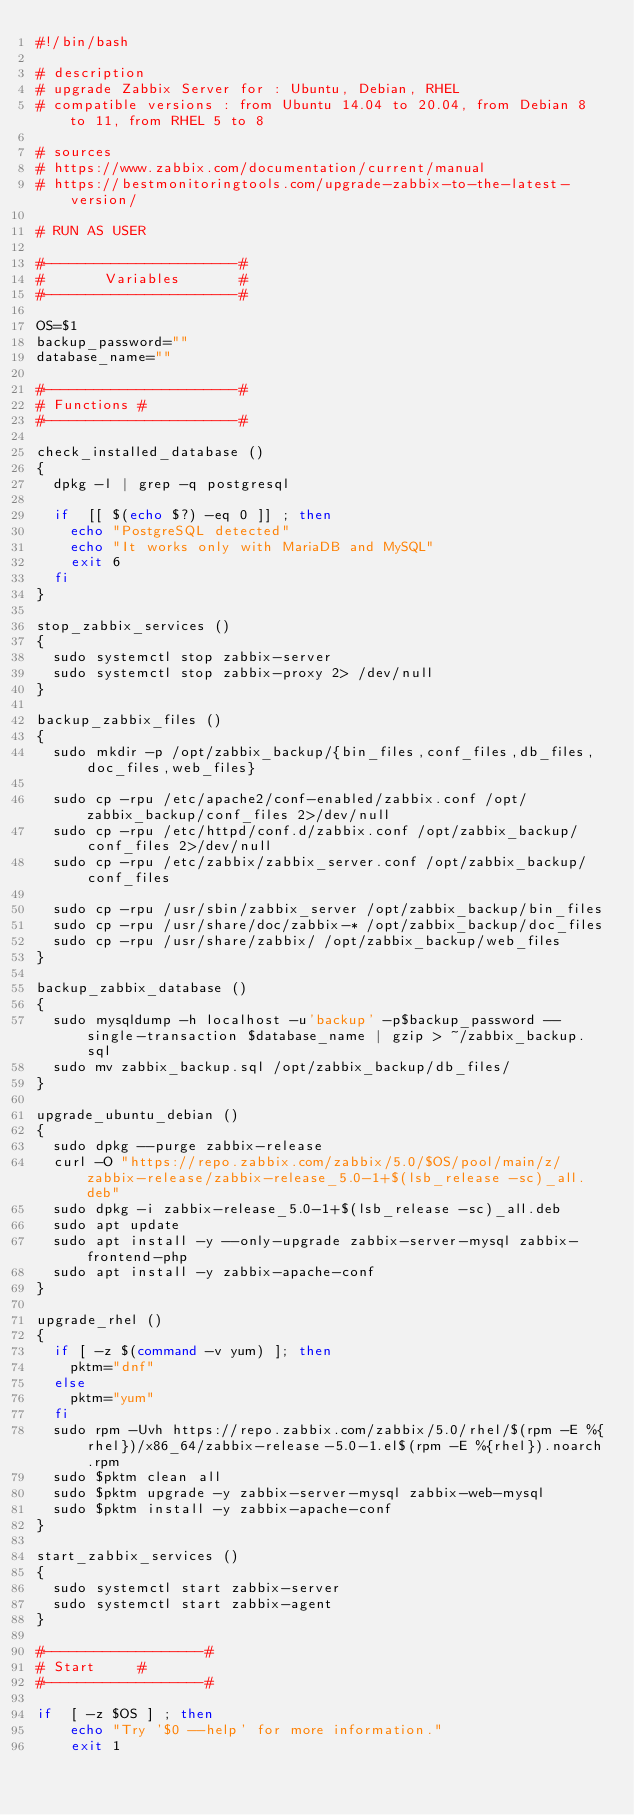Convert code to text. <code><loc_0><loc_0><loc_500><loc_500><_Bash_>#!/bin/bash

# description
# upgrade Zabbix Server for : Ubuntu, Debian, RHEL
# compatible versions : from Ubuntu 14.04 to 20.04, from Debian 8 to 11, from RHEL 5 to 8

# sources
# https://www.zabbix.com/documentation/current/manual
# https://bestmonitoringtools.com/upgrade-zabbix-to-the-latest-version/

# RUN AS USER

#-----------------------#
#       Variables       #
#-----------------------#

OS=$1
backup_password=""
database_name=""

#-----------------------#
#	Functions	#
#-----------------------#

check_installed_database ()
{
	dpkg -l | grep -q postgresql

	if	[[ $(echo $?) -eq 0 ]] ; then 
		echo "PostgreSQL detected"
		echo "It works only with MariaDB and MySQL"
		exit 6
	fi
}

stop_zabbix_services ()
{
	sudo systemctl stop zabbix-server
	sudo systemctl stop zabbix-proxy 2> /dev/null
}

backup_zabbix_files () 
{
	sudo mkdir -p /opt/zabbix_backup/{bin_files,conf_files,db_files,doc_files,web_files}
	
	sudo cp -rpu /etc/apache2/conf-enabled/zabbix.conf /opt/zabbix_backup/conf_files 2>/dev/null
	sudo cp -rpu /etc/httpd/conf.d/zabbix.conf /opt/zabbix_backup/conf_files 2>/dev/null
	sudo cp -rpu /etc/zabbix/zabbix_server.conf /opt/zabbix_backup/conf_files
	
	sudo cp -rpu /usr/sbin/zabbix_server /opt/zabbix_backup/bin_files
	sudo cp -rpu /usr/share/doc/zabbix-* /opt/zabbix_backup/doc_files
	sudo cp -rpu /usr/share/zabbix/ /opt/zabbix_backup/web_files
}

backup_zabbix_database ()
{
	sudo mysqldump -h localhost -u'backup' -p$backup_password --single-transaction $database_name | gzip > ~/zabbix_backup.sql
	sudo mv zabbix_backup.sql /opt/zabbix_backup/db_files/
}

upgrade_ubuntu_debian ()
{
	sudo dpkg --purge zabbix-release
	curl -O "https://repo.zabbix.com/zabbix/5.0/$OS/pool/main/z/zabbix-release/zabbix-release_5.0-1+$(lsb_release -sc)_all.deb"
	sudo dpkg -i zabbix-release_5.0-1+$(lsb_release -sc)_all.deb
	sudo apt update
	sudo apt install -y --only-upgrade zabbix-server-mysql zabbix-frontend-php
	sudo apt install -y zabbix-apache-conf
}

upgrade_rhel ()
{
	if [ -z $(command -v yum) ]; then
		pktm="dnf"
	else
		pktm="yum"
	fi
	sudo rpm -Uvh https://repo.zabbix.com/zabbix/5.0/rhel/$(rpm -E %{rhel})/x86_64/zabbix-release-5.0-1.el$(rpm -E %{rhel}).noarch.rpm
	sudo $pktm clean all
	sudo $pktm upgrade -y zabbix-server-mysql zabbix-web-mysql
	sudo $pktm install -y zabbix-apache-conf
}

start_zabbix_services ()
{
	sudo systemctl start zabbix-server
	sudo systemctl start zabbix-agent
}

#-------------------#
#	Start	    #
#-------------------#

if	[ -z $OS ] ; then
		echo "Try '$0 --help' for more information."
		exit 1
</code> 